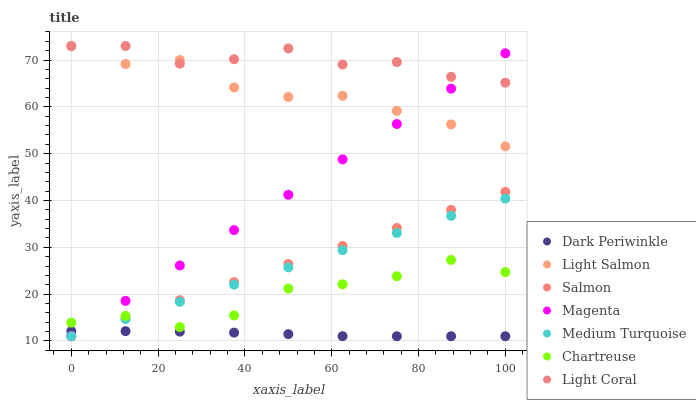Does Dark Periwinkle have the minimum area under the curve?
Answer yes or no. Yes. Does Light Coral have the maximum area under the curve?
Answer yes or no. Yes. Does Salmon have the minimum area under the curve?
Answer yes or no. No. Does Salmon have the maximum area under the curve?
Answer yes or no. No. Is Salmon the smoothest?
Answer yes or no. Yes. Is Chartreuse the roughest?
Answer yes or no. Yes. Is Light Coral the smoothest?
Answer yes or no. No. Is Light Coral the roughest?
Answer yes or no. No. Does Salmon have the lowest value?
Answer yes or no. Yes. Does Light Coral have the lowest value?
Answer yes or no. No. Does Light Coral have the highest value?
Answer yes or no. Yes. Does Salmon have the highest value?
Answer yes or no. No. Is Dark Periwinkle less than Light Salmon?
Answer yes or no. Yes. Is Light Salmon greater than Salmon?
Answer yes or no. Yes. Does Dark Periwinkle intersect Salmon?
Answer yes or no. Yes. Is Dark Periwinkle less than Salmon?
Answer yes or no. No. Is Dark Periwinkle greater than Salmon?
Answer yes or no. No. Does Dark Periwinkle intersect Light Salmon?
Answer yes or no. No. 